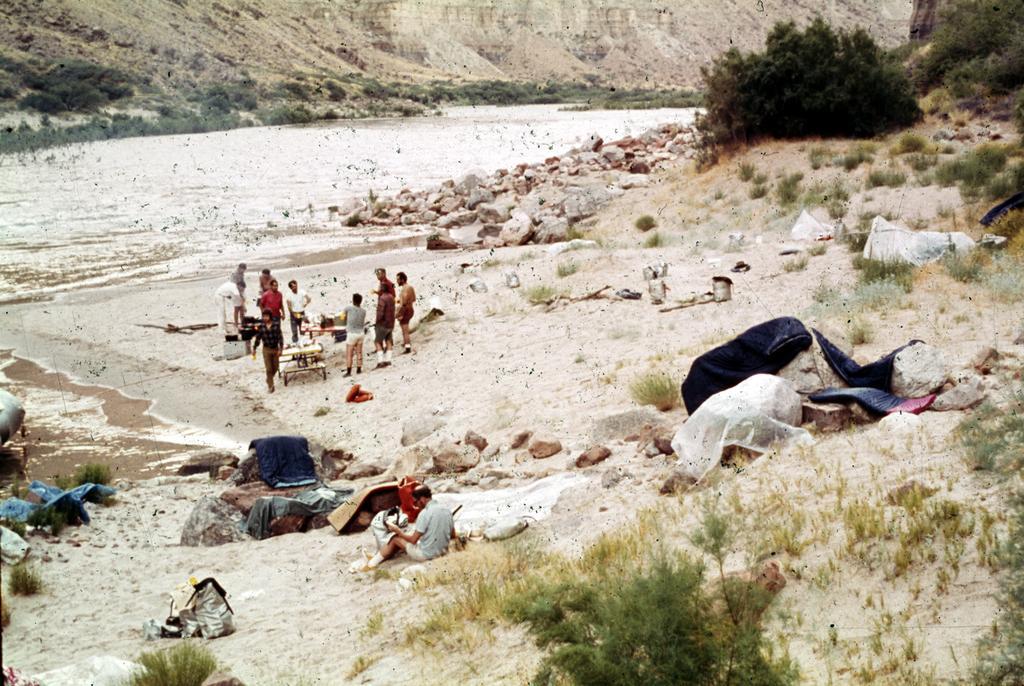Describe this image in one or two sentences. In this image we can see water, rocks, people, tables, plants, grass and things. 